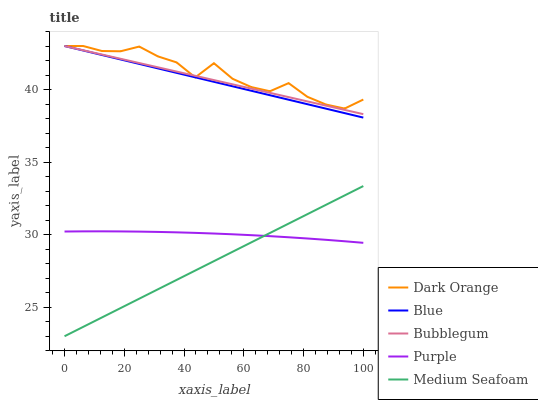Does Medium Seafoam have the minimum area under the curve?
Answer yes or no. Yes. Does Dark Orange have the maximum area under the curve?
Answer yes or no. Yes. Does Purple have the minimum area under the curve?
Answer yes or no. No. Does Purple have the maximum area under the curve?
Answer yes or no. No. Is Medium Seafoam the smoothest?
Answer yes or no. Yes. Is Dark Orange the roughest?
Answer yes or no. Yes. Is Purple the smoothest?
Answer yes or no. No. Is Purple the roughest?
Answer yes or no. No. Does Medium Seafoam have the lowest value?
Answer yes or no. Yes. Does Purple have the lowest value?
Answer yes or no. No. Does Bubblegum have the highest value?
Answer yes or no. Yes. Does Purple have the highest value?
Answer yes or no. No. Is Medium Seafoam less than Dark Orange?
Answer yes or no. Yes. Is Blue greater than Purple?
Answer yes or no. Yes. Does Blue intersect Dark Orange?
Answer yes or no. Yes. Is Blue less than Dark Orange?
Answer yes or no. No. Is Blue greater than Dark Orange?
Answer yes or no. No. Does Medium Seafoam intersect Dark Orange?
Answer yes or no. No. 